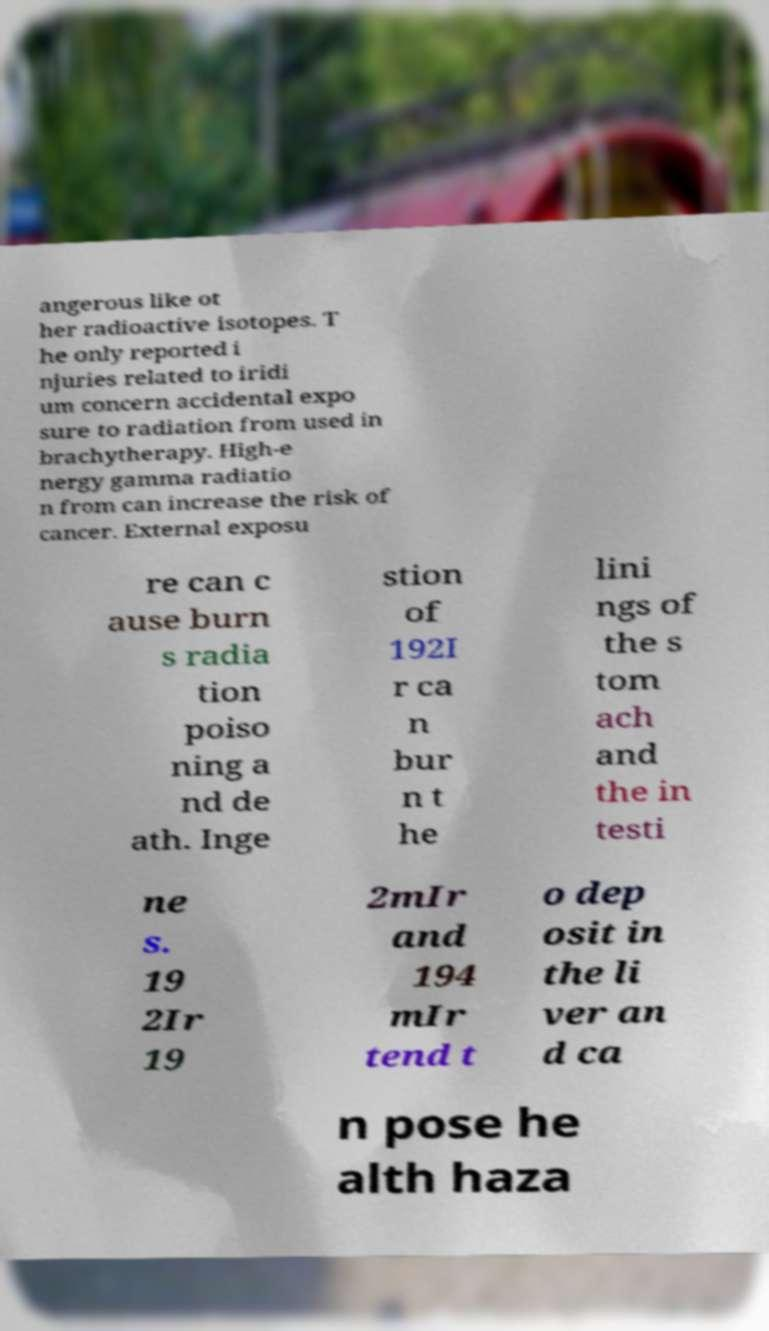Could you extract and type out the text from this image? angerous like ot her radioactive isotopes. T he only reported i njuries related to iridi um concern accidental expo sure to radiation from used in brachytherapy. High-e nergy gamma radiatio n from can increase the risk of cancer. External exposu re can c ause burn s radia tion poiso ning a nd de ath. Inge stion of 192I r ca n bur n t he lini ngs of the s tom ach and the in testi ne s. 19 2Ir 19 2mIr and 194 mIr tend t o dep osit in the li ver an d ca n pose he alth haza 